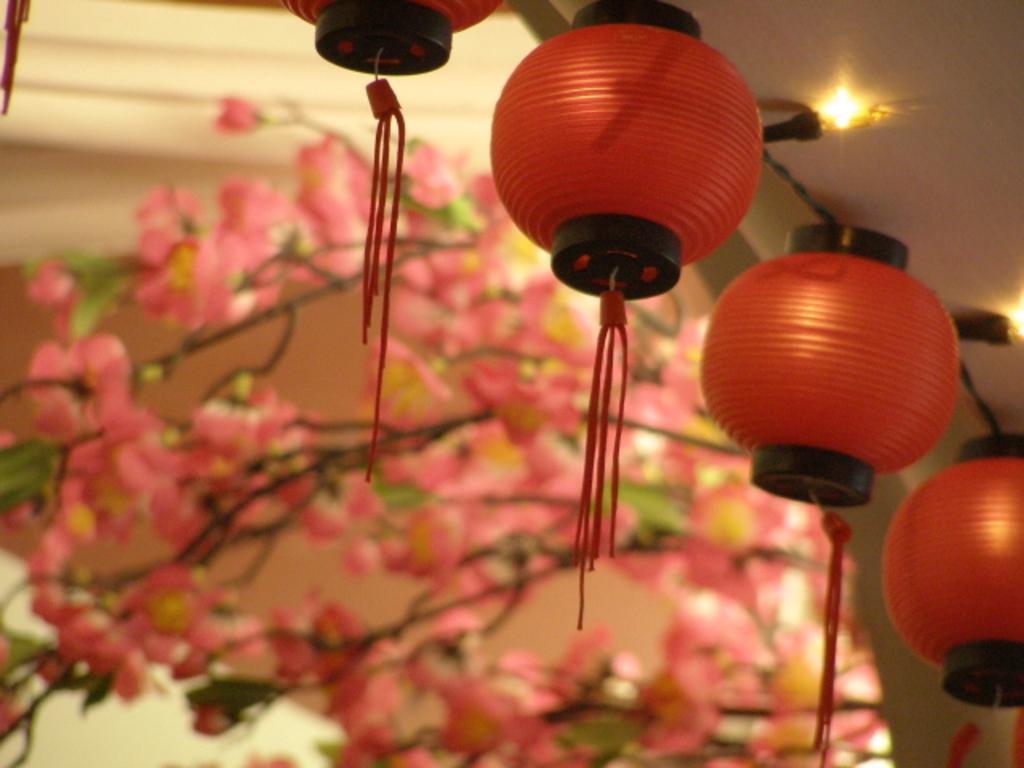Could you give a brief overview of what you see in this image? At the top right of the image there is a roof. There are a few lights and there are a few paper lamps. In the middle of image there is a plant with stems, leaves and many flowers which are pink in color. In the background there is a wall. 